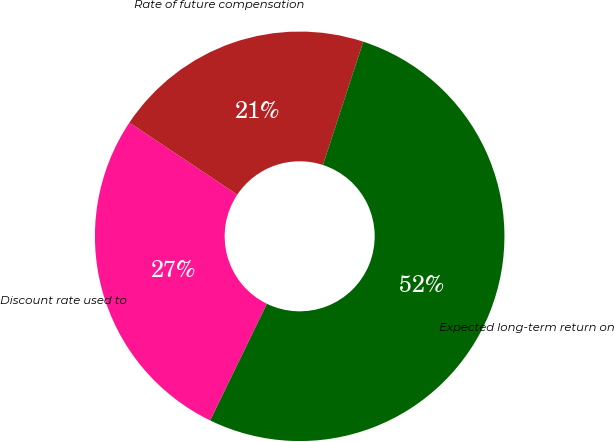Convert chart to OTSL. <chart><loc_0><loc_0><loc_500><loc_500><pie_chart><fcel>Discount rate used to<fcel>Rate of future compensation<fcel>Expected long-term return on<nl><fcel>27.17%<fcel>20.65%<fcel>52.17%<nl></chart> 